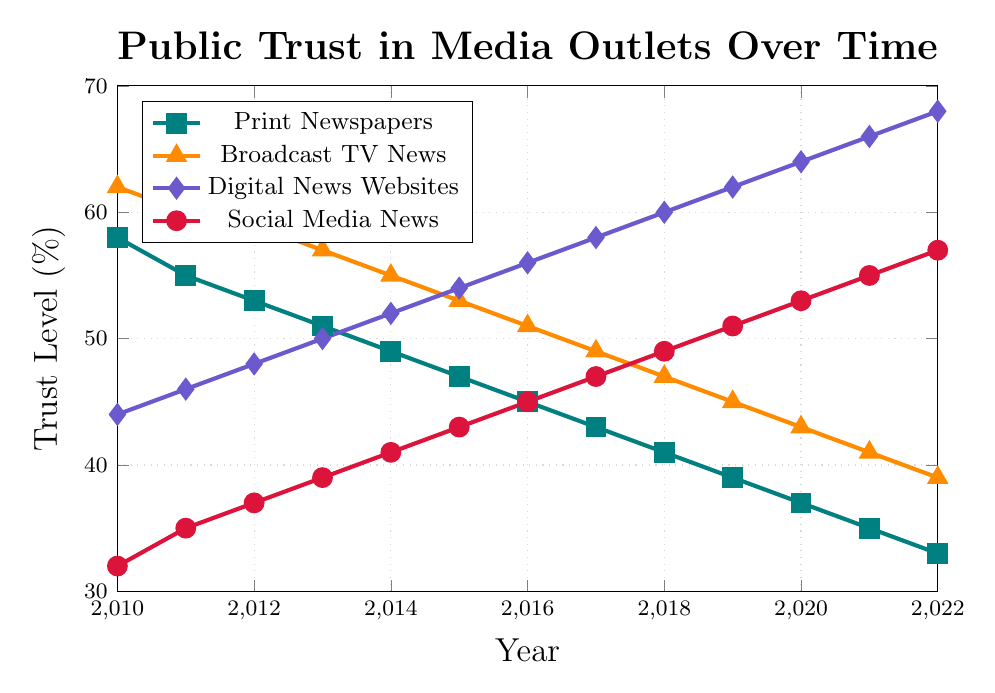What is the general trend of public trust in print newspapers from 2010 to 2022? From 2010 to 2022, the trust level in print newspapers consistently decreases. Each year shows a slight reduction in the percentage of public trust.
Answer: Decreasing trend Which media type had the highest trust level in 2022? Comparing the trust levels among all media types in 2022, the digital news websites had the highest trust level of 68%.
Answer: Digital News Websites In which year did social media news first surpass a 50% trust level? Reviewing the trust levels in social media news over the years, social media news first surpassed a 50% trust level in the year 2019 when it reached 51%.
Answer: 2019 How much did trust in broadcast TV news decrease between 2010 and 2022? Subtract the trust level in 2022 from the trust level in 2010 (62% - 39%).
Answer: 23% Which media type had the steepest increase in public trust over the period? By examining the slopes of the lines, digital news websites had the steepest increase going from 44% in 2010 to 68% in 2022, an increase of 24%.
Answer: Digital News Websites Rank the media types by their public trust levels in 2015. By reviewing the trust levels in 2015 for all media types: Broadcast TV News (53%), Print Newspapers (47%), Digital News Websites (54%), Social Media News (43%).
Answer: Digital News Websites > Broadcast TV News > Print Newspapers > Social Media News Did any media type show a constant trend in public trust? Reviewing the data, none of the media types showed a constant trend; all either increased or decreased over the period.
Answer: No What is the average trust level in broadcast TV news from 2010 to 2022? Add the trust levels for broadcast TV news from each year and divide by the number of years: (62 + 60 + 59 + 57 + 55 + 53 + 51 + 49 + 47 + 45 + 43 + 41 + 39)/13. Sum is 661, so the average is 661/13.
Answer: 50.85% How do trust levels in digital news websites compare to social media news in 2018? In 2018, trust in digital news websites reached 60%, whereas trust in social media news was 49%. Digital news websites had higher trust levels.
Answer: Digital News Websites higher 